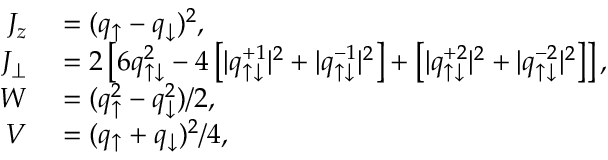<formula> <loc_0><loc_0><loc_500><loc_500>\begin{array} { r l } { J _ { z } } & = ( q _ { \uparrow } - q _ { \downarrow } ) ^ { 2 } , } \\ { J _ { \perp } } & = 2 \left [ 6 q _ { \uparrow \downarrow } ^ { 2 } - 4 \left [ | q _ { \uparrow \downarrow } ^ { + 1 } | ^ { 2 } + | q _ { \uparrow \downarrow } ^ { - 1 } | ^ { 2 } \right ] + \left [ | q _ { \uparrow \downarrow } ^ { + 2 } | ^ { 2 } + | q _ { \uparrow \downarrow } ^ { - 2 } | ^ { 2 } \right ] \right ] , } \\ { W } & = ( q _ { \uparrow } ^ { 2 } - q _ { \downarrow } ^ { 2 } ) / 2 , } \\ { V } & = ( q _ { \uparrow } + q _ { \downarrow } ) ^ { 2 } / 4 , } \end{array}</formula> 